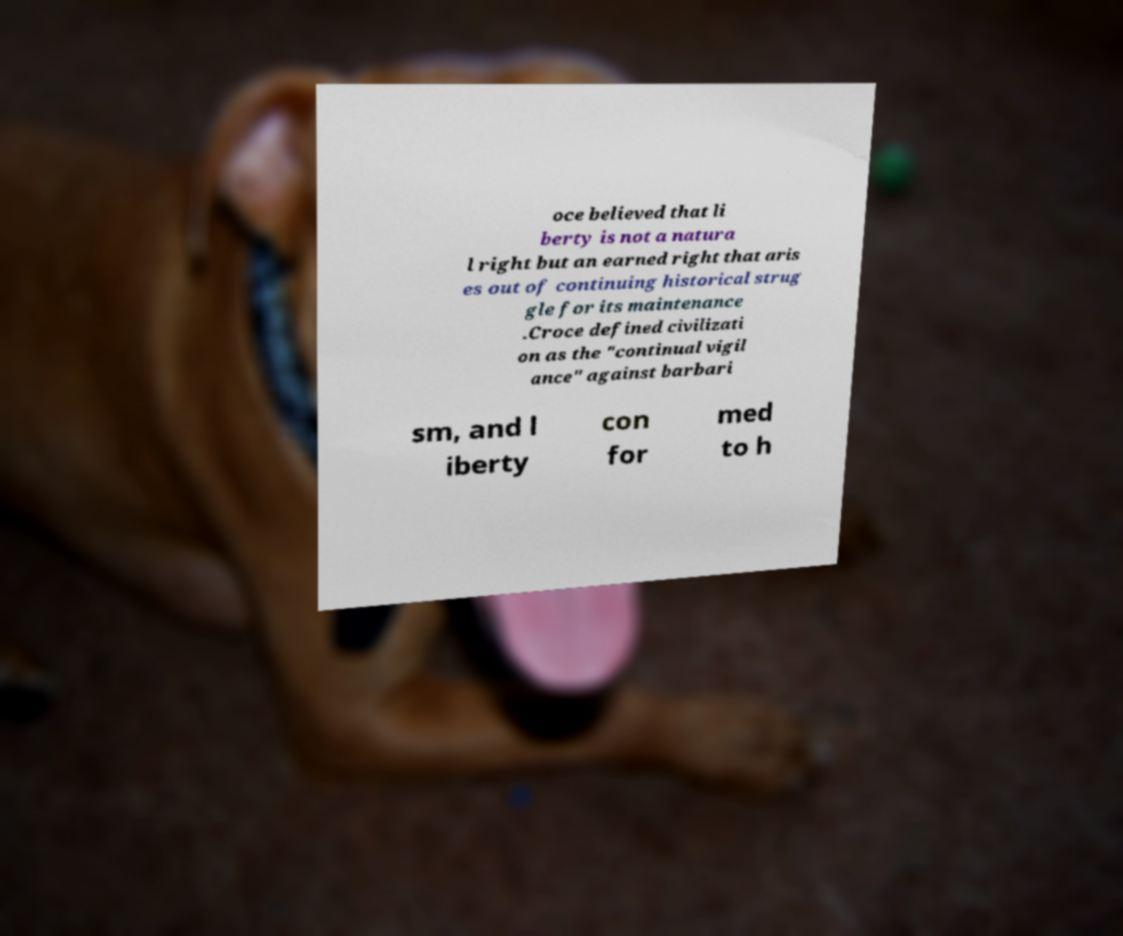For documentation purposes, I need the text within this image transcribed. Could you provide that? oce believed that li berty is not a natura l right but an earned right that aris es out of continuing historical strug gle for its maintenance .Croce defined civilizati on as the "continual vigil ance" against barbari sm, and l iberty con for med to h 